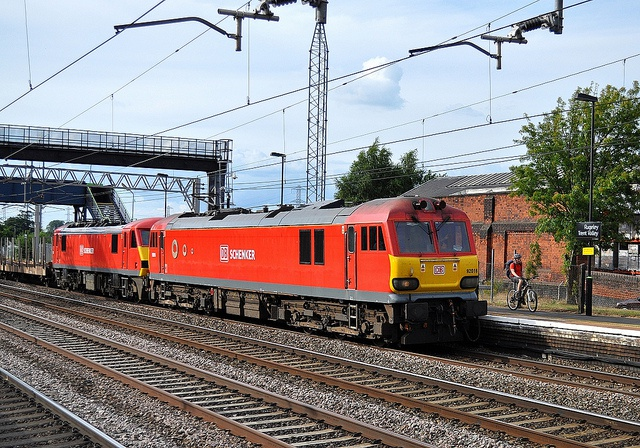Describe the objects in this image and their specific colors. I can see train in lightblue, black, red, and gray tones, bicycle in lightblue, black, gray, darkgray, and tan tones, people in lightblue, black, gray, and maroon tones, car in lightblue, gray, and black tones, and backpack in lightblue, black, gray, and maroon tones in this image. 